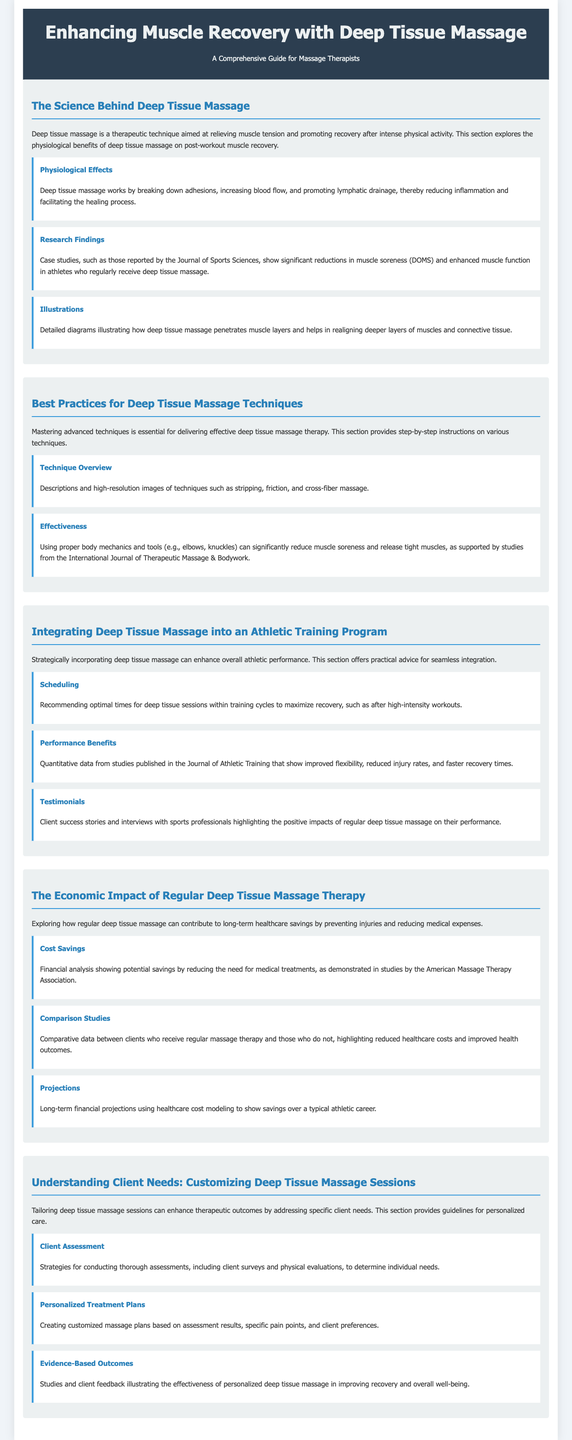What is the title of the whitepaper? The title of the whitepaper is stated at the top of the document.
Answer: Enhancing Muscle Recovery with Deep Tissue Massage What is one physiological effect of deep tissue massage? The document details the benefits of deep tissue massage, including specific physiological effects.
Answer: Increasing blood flow Which journal reported significant reductions in muscle soreness? The whitepaper references a specific journal for its findings on muscle soreness related to deep tissue massage.
Answer: Journal of Sports Sciences What technique is highlighted in the best practices section? The section describes various advanced techniques used in deep tissue massage.
Answer: Stripping What is one benefit of integrating deep tissue massage into an athletic training program? The document outlines the positive impacts of incorporating deep tissue massage in athletic training.
Answer: Improved flexibility How can deep tissue massage affect healthcare costs? The whitepaper explores the financial implications of regular deep tissue massage.
Answer: Reducing medical expenses What method is suggested for assessing client needs? The document provides strategies for evaluating individual client requirements.
Answer: Client surveys What is the economic impact of regular deep tissue massage therapy? The whitepaper discusses the financial benefits associated with regular massage therapy.
Answer: Long-term healthcare savings 